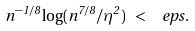Convert formula to latex. <formula><loc_0><loc_0><loc_500><loc_500>n ^ { - 1 / 8 } \log ( n ^ { 7 / 8 } / \eta ^ { 2 } ) \ < \ \ e p s .</formula> 